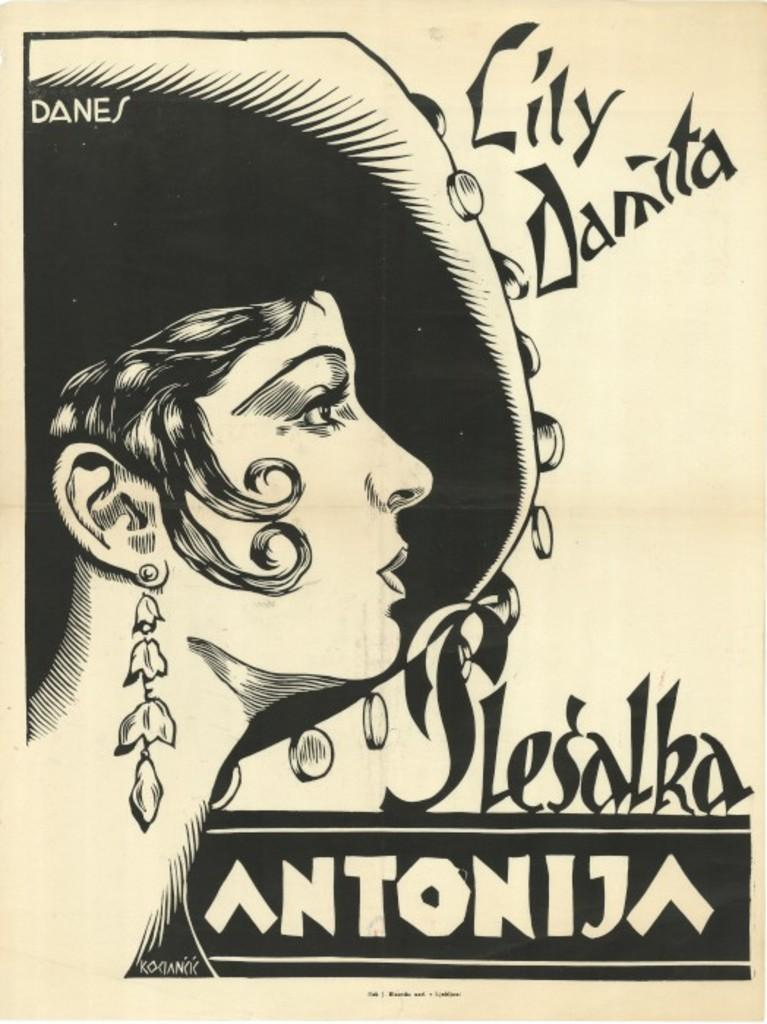What is depicted in the picture? There is a drawing of a lady in the picture. What is the lady wearing in the drawing? The lady is wearing a hat in the drawing. What type of silk material is used to make the lady's hat in the drawing? There is no mention of silk or any specific material used for the hat in the drawing. The lady's hat is simply depicted in the drawing, but its composition is not described. 